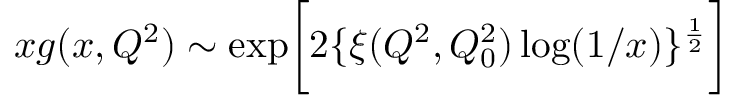Convert formula to latex. <formula><loc_0><loc_0><loc_500><loc_500>x g ( x , Q ^ { 2 } ) \sim \exp \left [ 2 \{ \xi ( Q ^ { 2 } , Q _ { 0 } ^ { 2 } ) \log ( 1 / x ) \} ^ { \frac { 1 } { 2 } } \right ]</formula> 